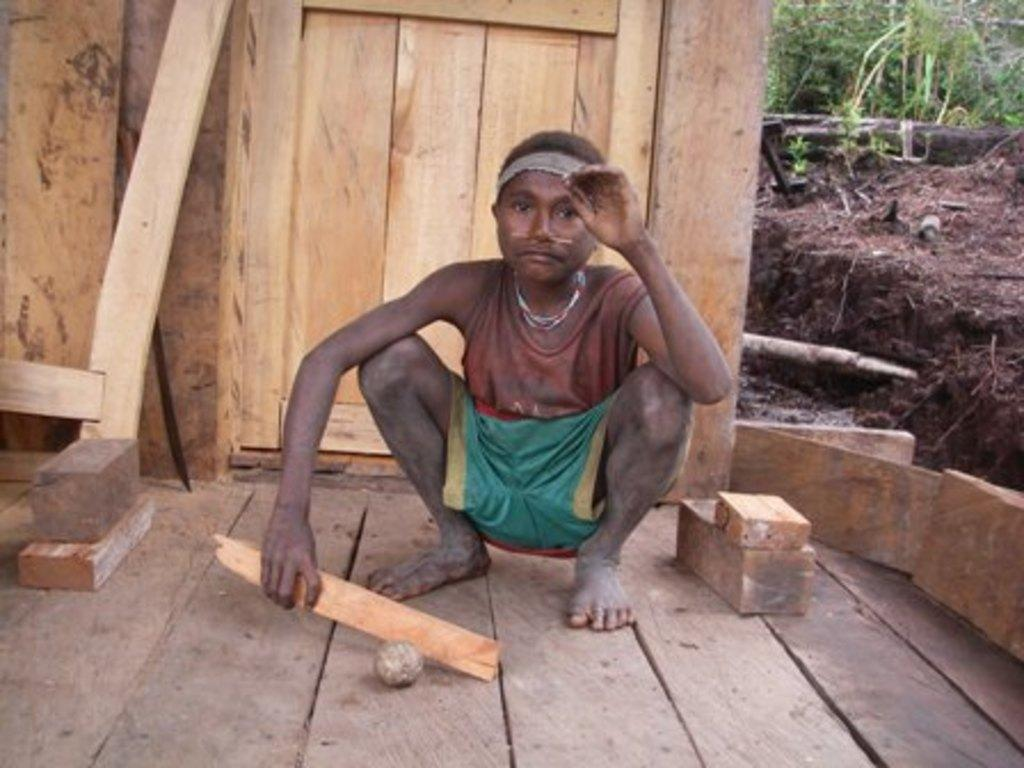What is the person in the image holding? The person in the image is holding a wooden stick. What type of terrain is visible in the background? Green grass and mud are visible in the background. What type of objects can be seen in the background? There are wooden objects in the background. What type of fruit is the person holding in the image? The person is not holding any fruit in the image; they are holding a wooden stick. What type of approval is the person seeking in the image? There is no indication in the image that the person is seeking any approval. 